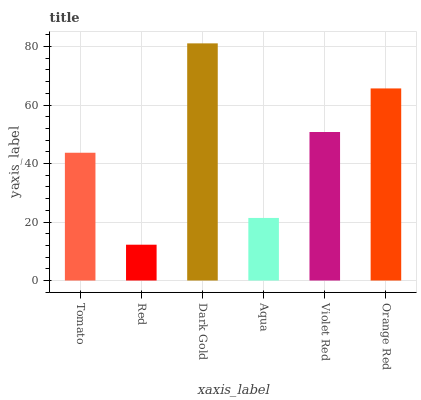Is Red the minimum?
Answer yes or no. Yes. Is Dark Gold the maximum?
Answer yes or no. Yes. Is Dark Gold the minimum?
Answer yes or no. No. Is Red the maximum?
Answer yes or no. No. Is Dark Gold greater than Red?
Answer yes or no. Yes. Is Red less than Dark Gold?
Answer yes or no. Yes. Is Red greater than Dark Gold?
Answer yes or no. No. Is Dark Gold less than Red?
Answer yes or no. No. Is Violet Red the high median?
Answer yes or no. Yes. Is Tomato the low median?
Answer yes or no. Yes. Is Orange Red the high median?
Answer yes or no. No. Is Dark Gold the low median?
Answer yes or no. No. 